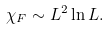<formula> <loc_0><loc_0><loc_500><loc_500>\chi _ { F } \sim L ^ { 2 } \ln L .</formula> 